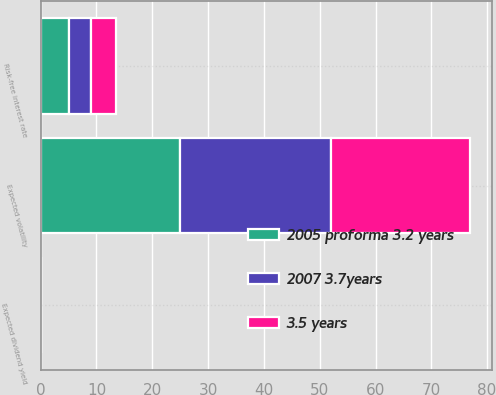<chart> <loc_0><loc_0><loc_500><loc_500><stacked_bar_chart><ecel><fcel>Expected volatility<fcel>Expected dividend yield<fcel>Risk-free interest rate<nl><fcel>3.5 years<fcel>25<fcel>0<fcel>4.4<nl><fcel>2005 proforma 3.2 years<fcel>25<fcel>0<fcel>5<nl><fcel>2007 3.7years<fcel>27<fcel>0<fcel>4.1<nl></chart> 